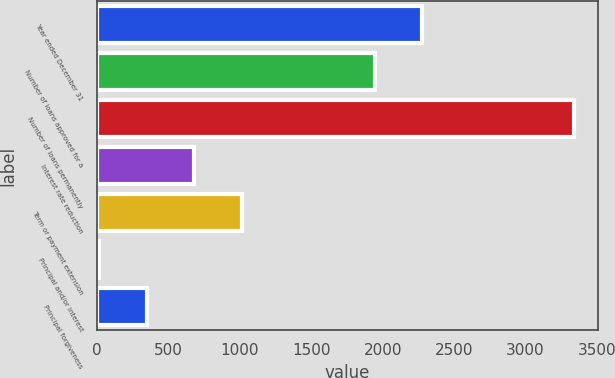Convert chart to OTSL. <chart><loc_0><loc_0><loc_500><loc_500><bar_chart><fcel>Year ended December 31<fcel>Number of loans approved for a<fcel>Number of loans permanently<fcel>Interest rate reduction<fcel>Term or payment extension<fcel>Principal and/or interest<fcel>Principal forgiveness<nl><fcel>2277.2<fcel>1945<fcel>3338<fcel>680.4<fcel>1012.6<fcel>16<fcel>348.2<nl></chart> 